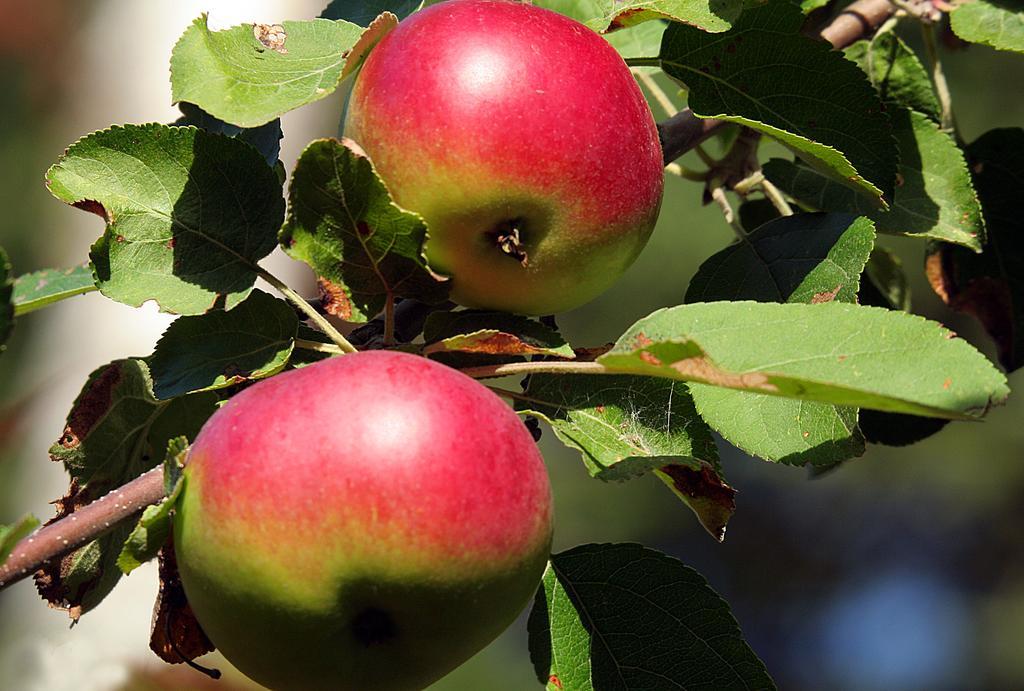Please provide a concise description of this image. In this image we can see two fruits and the branch of a tree, also the background is blurred. 